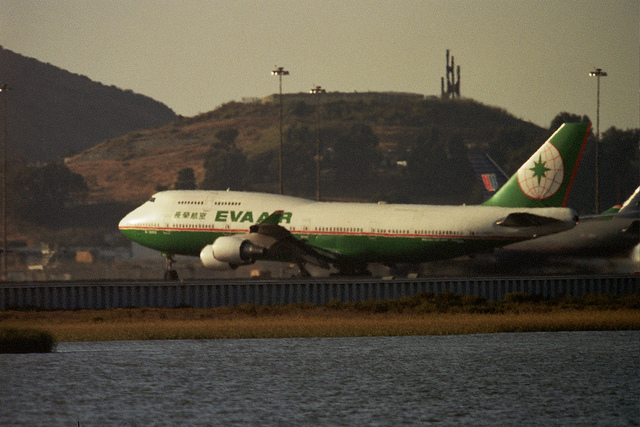Identify the text displayed in this image. EVA 